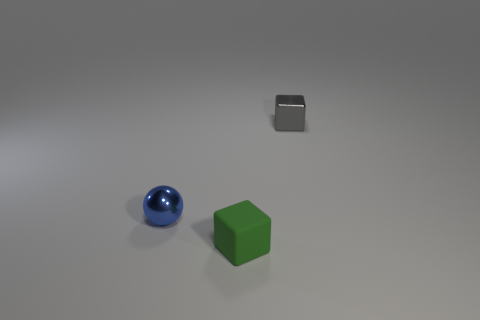Add 3 red matte cubes. How many objects exist? 6 Subtract all balls. How many objects are left? 2 Subtract 1 green blocks. How many objects are left? 2 Subtract all cyan shiny balls. Subtract all tiny blue things. How many objects are left? 2 Add 2 matte objects. How many matte objects are left? 3 Add 2 matte objects. How many matte objects exist? 3 